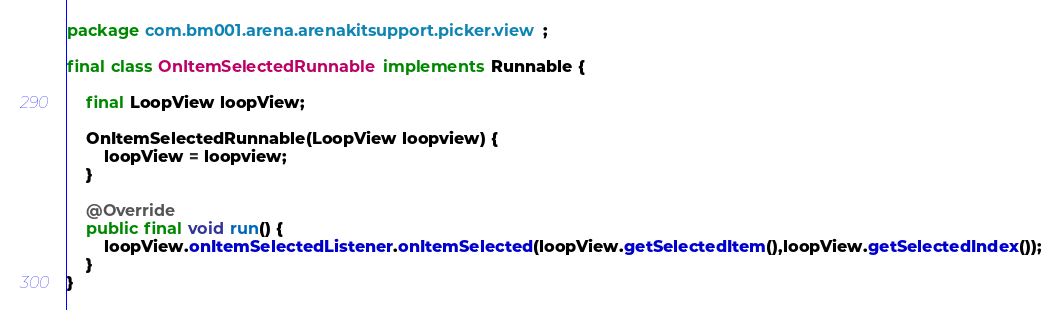Convert code to text. <code><loc_0><loc_0><loc_500><loc_500><_Java_>package com.bm001.arena.arenakitsupport.picker.view;

final class OnItemSelectedRunnable implements Runnable {

    final LoopView loopView;

    OnItemSelectedRunnable(LoopView loopview) {
        loopView = loopview;
    }

    @Override
    public final void run() {
        loopView.onItemSelectedListener.onItemSelected(loopView.getSelectedItem(),loopView.getSelectedIndex());
    }
}
</code> 